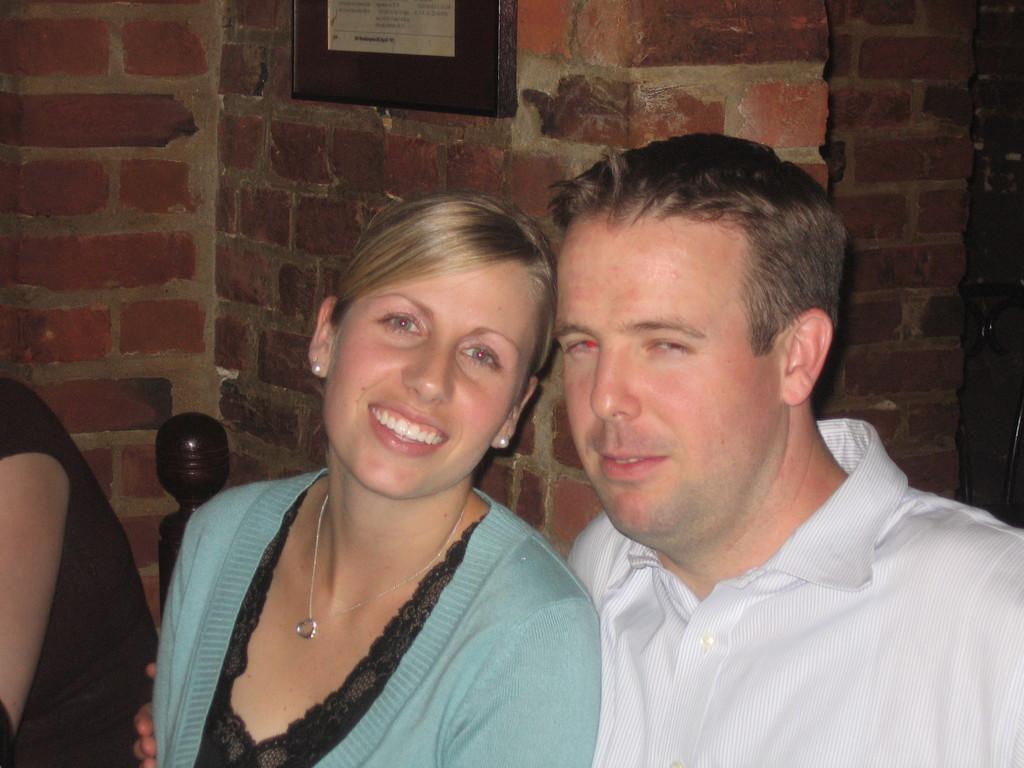In one or two sentences, can you explain what this image depicts? In this there are three persons sitting on the chairs. At the back side there is a wall with the photo frame on it. 